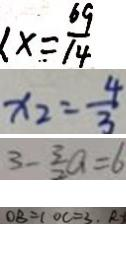<formula> <loc_0><loc_0><loc_500><loc_500>x = \frac { 6 9 } { 1 4 } 
 x _ { 2 } = \frac { 4 } { 3 } 
 3 - \frac { 3 } { 2 } a = 6 
 O B = 1 O C = 3 . R</formula> 